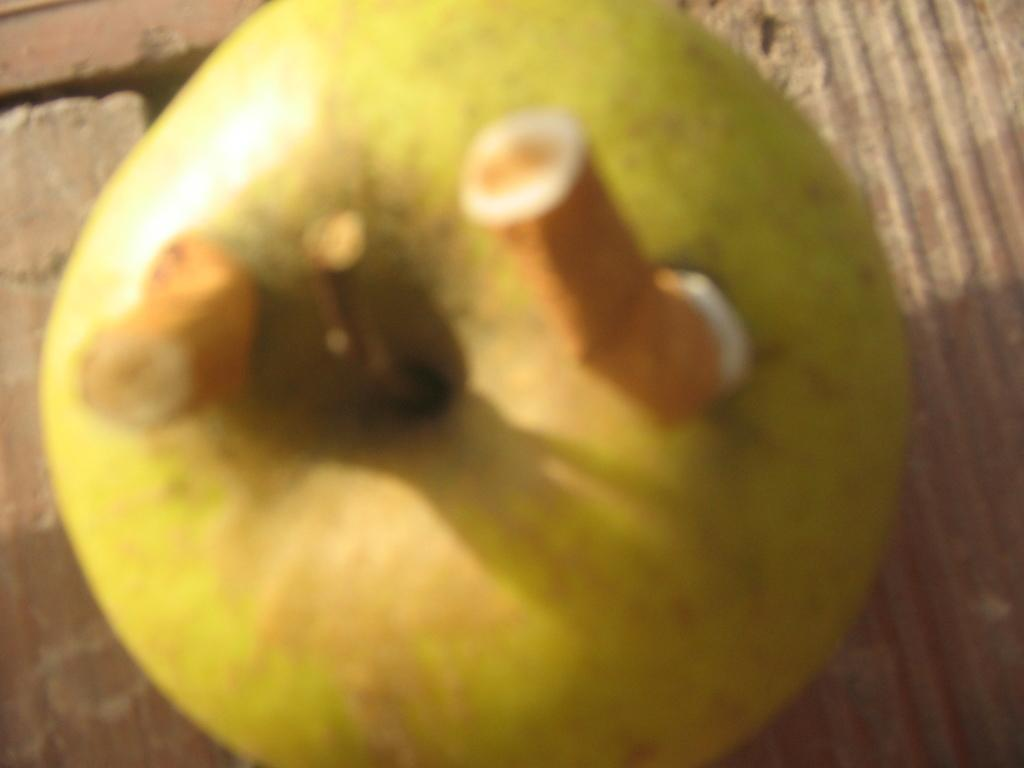What is the overall quality of the image? The image is blurred. Can you identify any specific objects in the image? There may be an apple in the image. Are there any additional items on the apple? There may be two half cigarettes on the apple in the image. What type of light is being advertised in the image? There is no light or advertisement present in the image. Can you tell me the order in which the items were placed on the apple? The provided facts do not give information about the order in which the items were placed on the apple. 